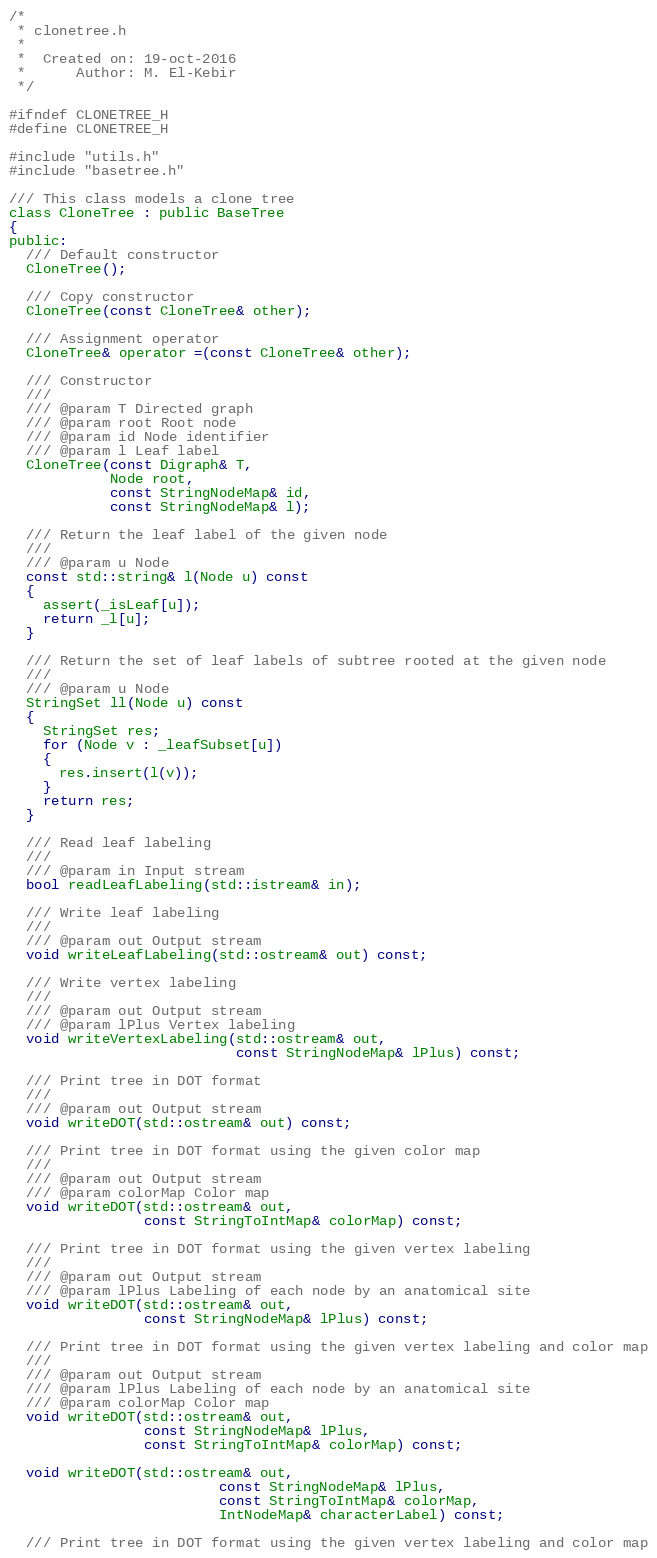<code> <loc_0><loc_0><loc_500><loc_500><_C_>/*
 * clonetree.h
 *
 *  Created on: 19-oct-2016
 *      Author: M. El-Kebir
 */

#ifndef CLONETREE_H
#define CLONETREE_H

#include "utils.h"
#include "basetree.h"

/// This class models a clone tree
class CloneTree : public BaseTree
{
public:
  /// Default constructor
  CloneTree();
  
  /// Copy constructor
  CloneTree(const CloneTree& other);
  
  /// Assignment operator
  CloneTree& operator =(const CloneTree& other);
  
  /// Constructor
  ///
  /// @param T Directed graph
  /// @param root Root node
  /// @param id Node identifier
  /// @param l Leaf label
  CloneTree(const Digraph& T,
            Node root,
            const StringNodeMap& id,
            const StringNodeMap& l);
  
  /// Return the leaf label of the given node
  ///
  /// @param u Node
  const std::string& l(Node u) const
  {
    assert(_isLeaf[u]);
    return _l[u];
  }
  
  /// Return the set of leaf labels of subtree rooted at the given node
  ///
  /// @param u Node
  StringSet ll(Node u) const
  {
    StringSet res;
    for (Node v : _leafSubset[u])
    {
      res.insert(l(v));
    }
    return res;
  }
  
  /// Read leaf labeling
  ///
  /// @param in Input stream
  bool readLeafLabeling(std::istream& in);
  
  /// Write leaf labeling
  ///
  /// @param out Output stream
  void writeLeafLabeling(std::ostream& out) const;
  
  /// Write vertex labeling
  ///
  /// @param out Output stream
  /// @param lPlus Vertex labeling
  void writeVertexLabeling(std::ostream& out,
                           const StringNodeMap& lPlus) const;
  
  /// Print tree in DOT format
  ///
  /// @param out Output stream
  void writeDOT(std::ostream& out) const;
  
  /// Print tree in DOT format using the given color map
  ///
  /// @param out Output stream
  /// @param colorMap Color map
  void writeDOT(std::ostream& out,
                const StringToIntMap& colorMap) const;
  
  /// Print tree in DOT format using the given vertex labeling
  ///
  /// @param out Output stream
  /// @param lPlus Labeling of each node by an anatomical site
  void writeDOT(std::ostream& out,
                const StringNodeMap& lPlus) const;
  
  /// Print tree in DOT format using the given vertex labeling and color map
  ///
  /// @param out Output stream
  /// @param lPlus Labeling of each node by an anatomical site
  /// @param colorMap Color map
  void writeDOT(std::ostream& out,
                const StringNodeMap& lPlus,
                const StringToIntMap& colorMap) const;

  void writeDOT(std::ostream& out,
                         const StringNodeMap& lPlus,
                         const StringToIntMap& colorMap,
                         IntNodeMap& characterLabel) const;
  
  /// Print tree in DOT format using the given vertex labeling and color map</code> 